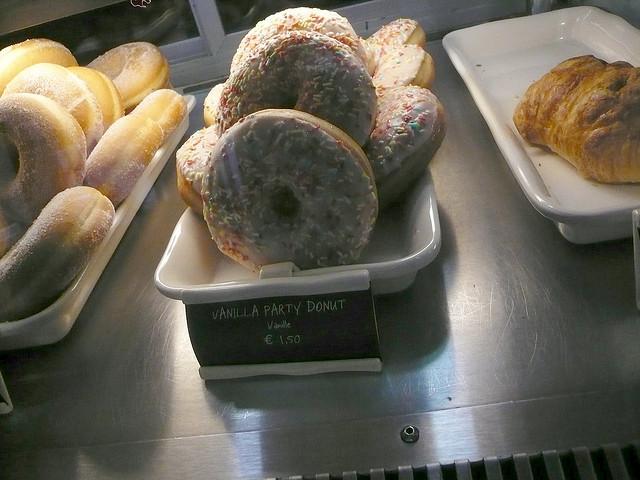How many of these donuts is it healthy to eat?
Be succinct. 0. What kind of vanilla extract is in the donut?
Write a very short answer. Party. How many pastries on the right tray?
Be succinct. 1. 